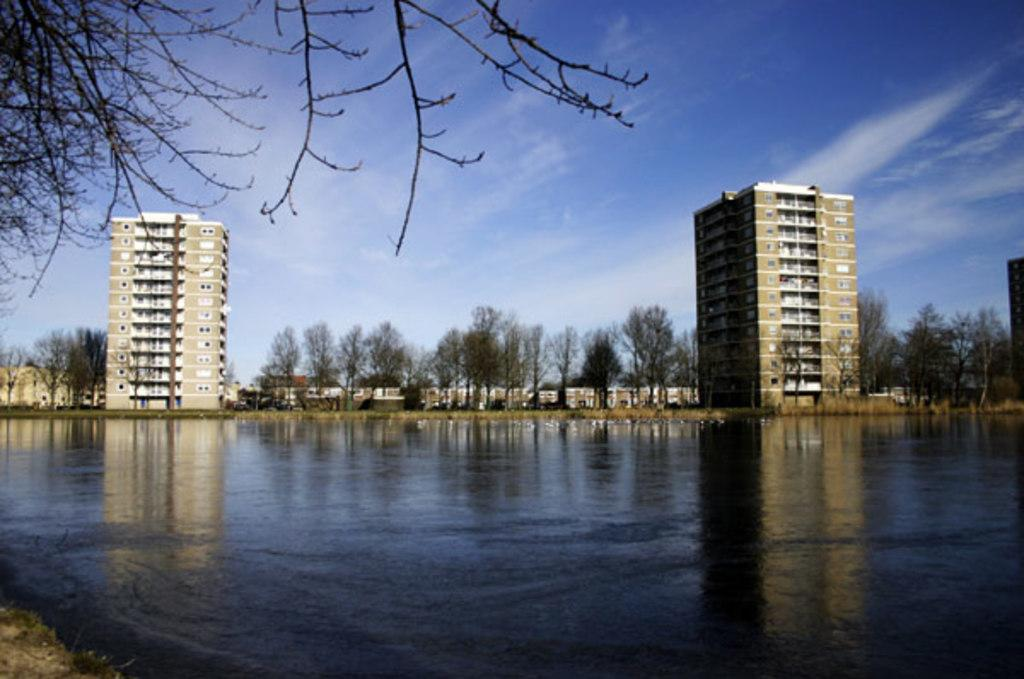What is the main subject in the center of the image? There is water in the center of the image. What can be seen in the background of the image? There are buildings and trees in the background of the image. Where are the leaves located in the image? The leaves are present on the top left of the image. How would you describe the sky in the image? The sky is cloudy in the image. What type of prose is being recited by the trees in the image? There is no prose being recited by the trees in the image, as trees do not have the ability to recite prose. 